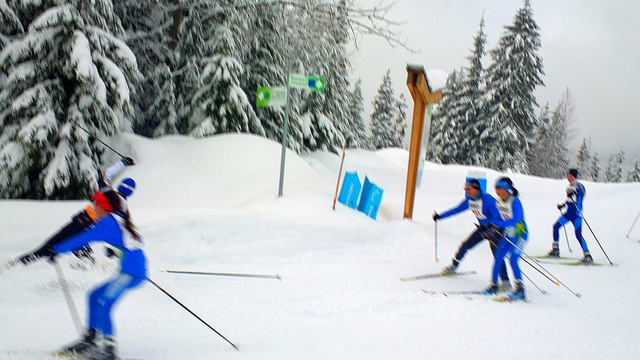Describe the objects in this image and their specific colors. I can see people in darkgray, blue, darkblue, and black tones, people in darkgray, darkblue, and blue tones, people in darkgray, black, darkblue, navy, and gray tones, people in darkgray, black, and gray tones, and people in darkgray, navy, blue, and gray tones in this image. 